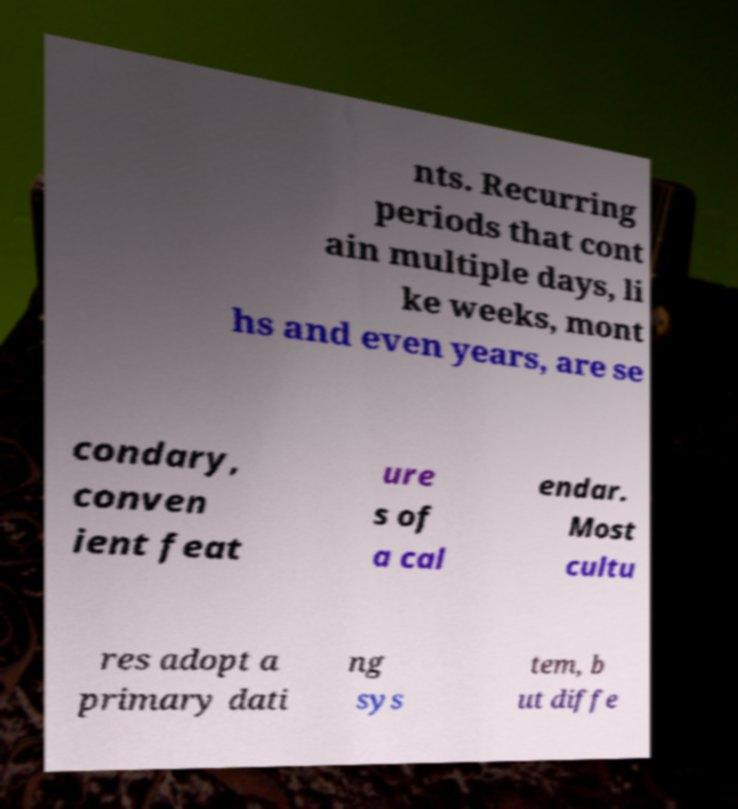For documentation purposes, I need the text within this image transcribed. Could you provide that? nts. Recurring periods that cont ain multiple days, li ke weeks, mont hs and even years, are se condary, conven ient feat ure s of a cal endar. Most cultu res adopt a primary dati ng sys tem, b ut diffe 